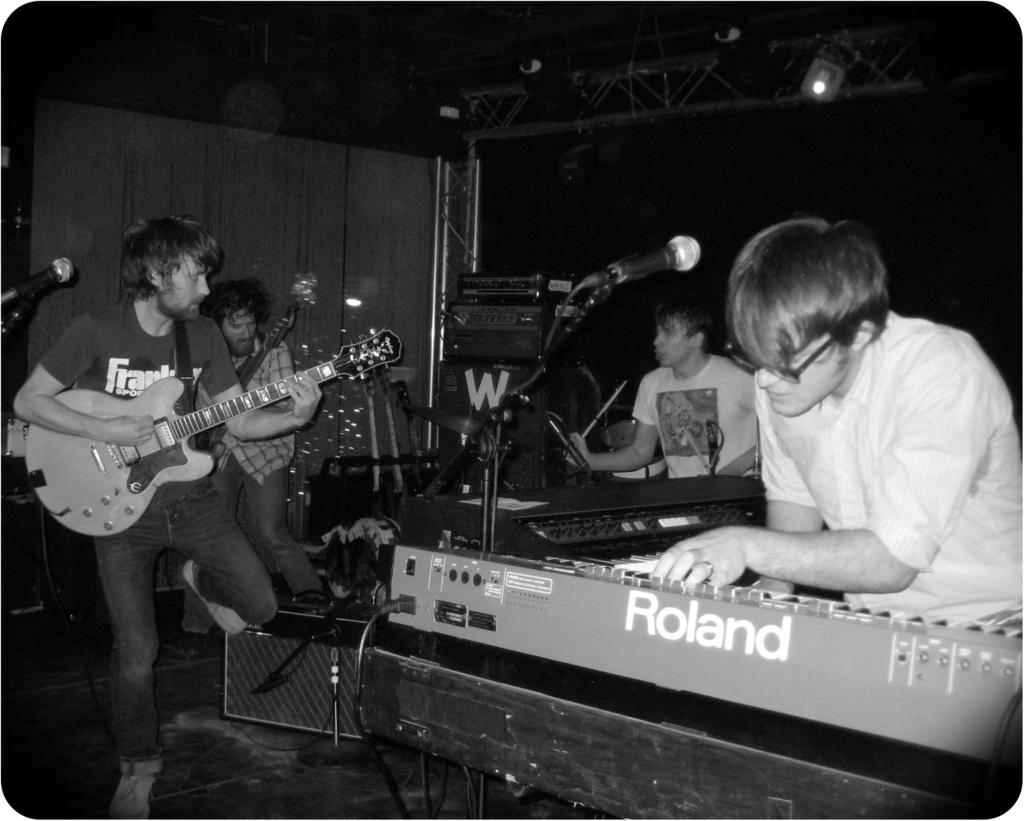<image>
Share a concise interpretation of the image provided. A man is playing a Roland electric keyboard with other members of a rock band. 